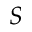<formula> <loc_0><loc_0><loc_500><loc_500>S</formula> 